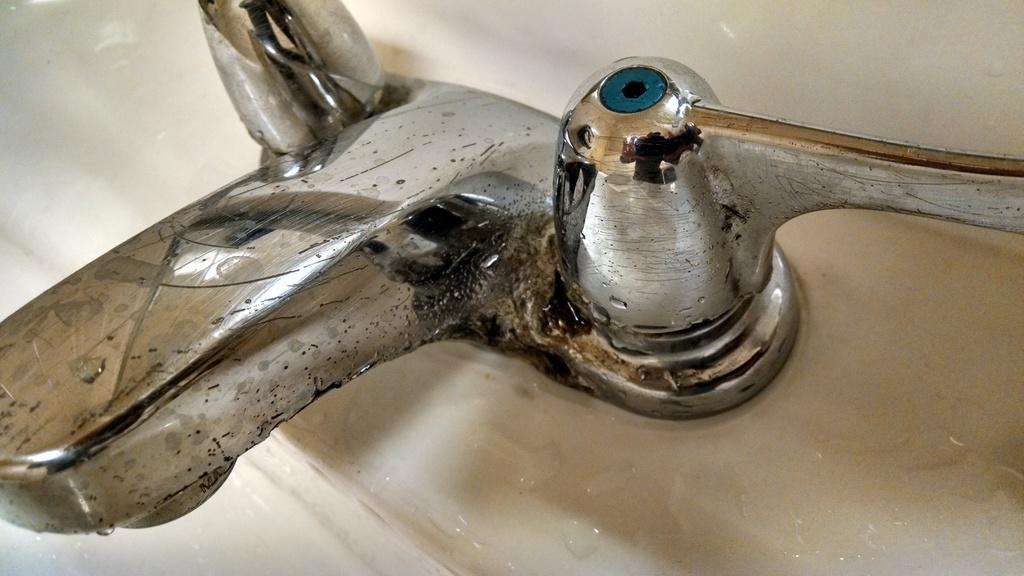What is the main object in the center of the image? There is a tap in the center of the image. What type of treatment is being administered to the bulb in the image? There is no bulb present in the image, and therefore no treatment can be observed. What type of furniture is visible in the image? There is no furniture visible in the image; only a tap is present. 